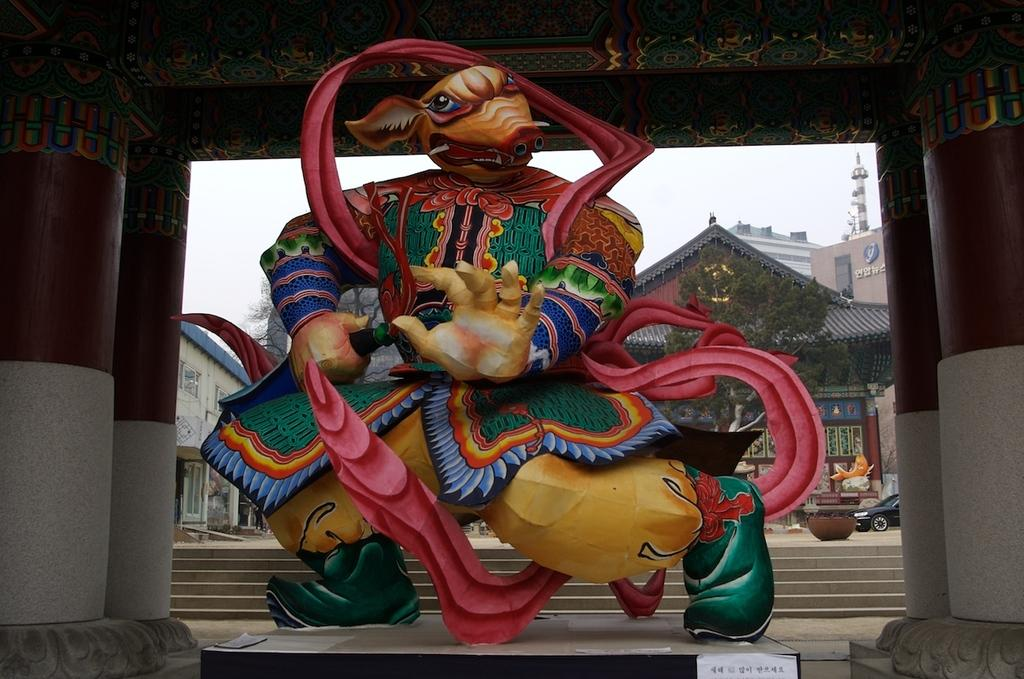What is the main structure featured in the image? There is a temple in the image. What other objects or features can be seen in the image? There is a statue, a tree, a car, and the sky is visible in the image. What type of pancake is being printed on the car in the image? There is no pancake or printing on the car in the image; it is a regular car parked near the temple. 